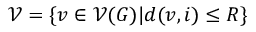Convert formula to latex. <formula><loc_0><loc_0><loc_500><loc_500>\mathcal { V } = \left \{ v \in \mathcal { V } ( G ) | d ( v , i ) \leq R \right \}</formula> 